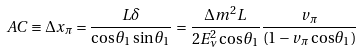Convert formula to latex. <formula><loc_0><loc_0><loc_500><loc_500>A C \equiv \Delta x _ { \pi } = \frac { L \delta } { \cos \theta _ { 1 } \sin \theta _ { 1 } } = \frac { \Delta m ^ { 2 } L } { 2 E _ { \nu } ^ { 2 } \cos \theta _ { 1 } } \frac { v _ { \pi } } { ( 1 - v _ { \pi } \cos \theta _ { 1 } ) }</formula> 